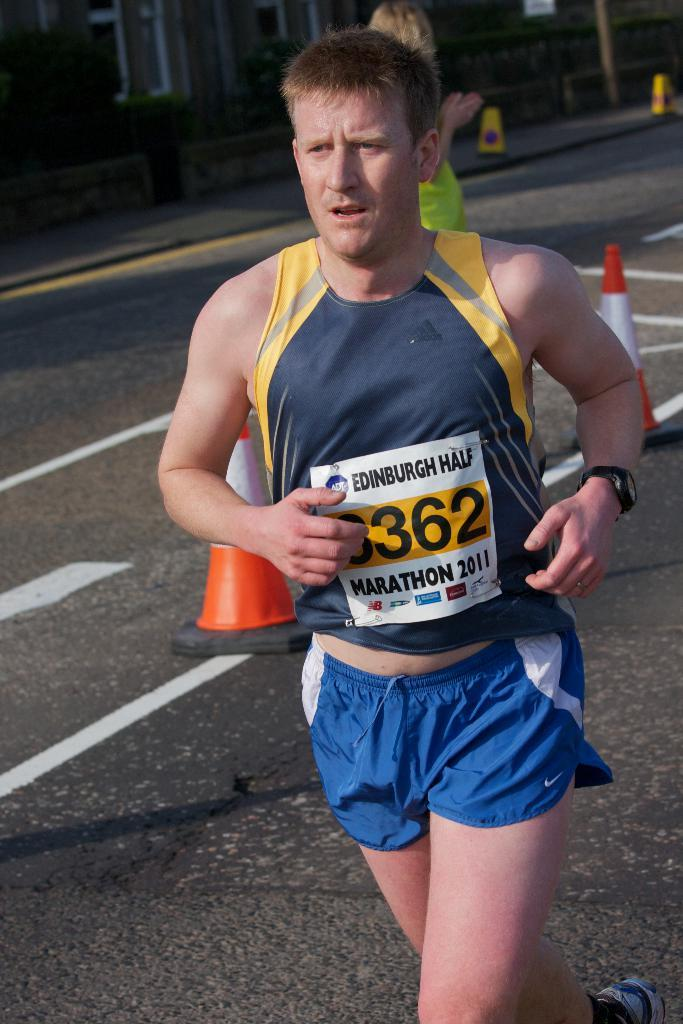<image>
Provide a brief description of the given image. a person with the numbers 3362 on the front 